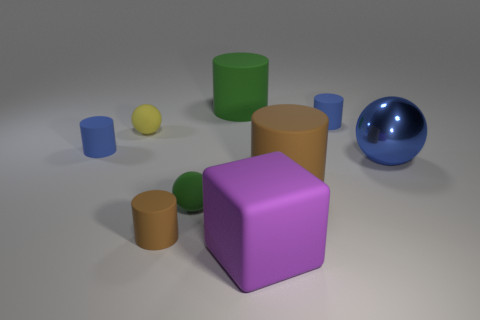Subtract all large green cylinders. How many cylinders are left? 4 Add 1 small matte cubes. How many objects exist? 10 Subtract all blue spheres. How many spheres are left? 2 Subtract all cylinders. How many objects are left? 4 Subtract all red blocks. Subtract all red spheres. How many blocks are left? 1 Subtract all blue spheres. How many green cylinders are left? 1 Subtract all big blue metal cylinders. Subtract all purple matte blocks. How many objects are left? 8 Add 3 large objects. How many large objects are left? 7 Add 3 big blue matte blocks. How many big blue matte blocks exist? 3 Subtract 0 red blocks. How many objects are left? 9 